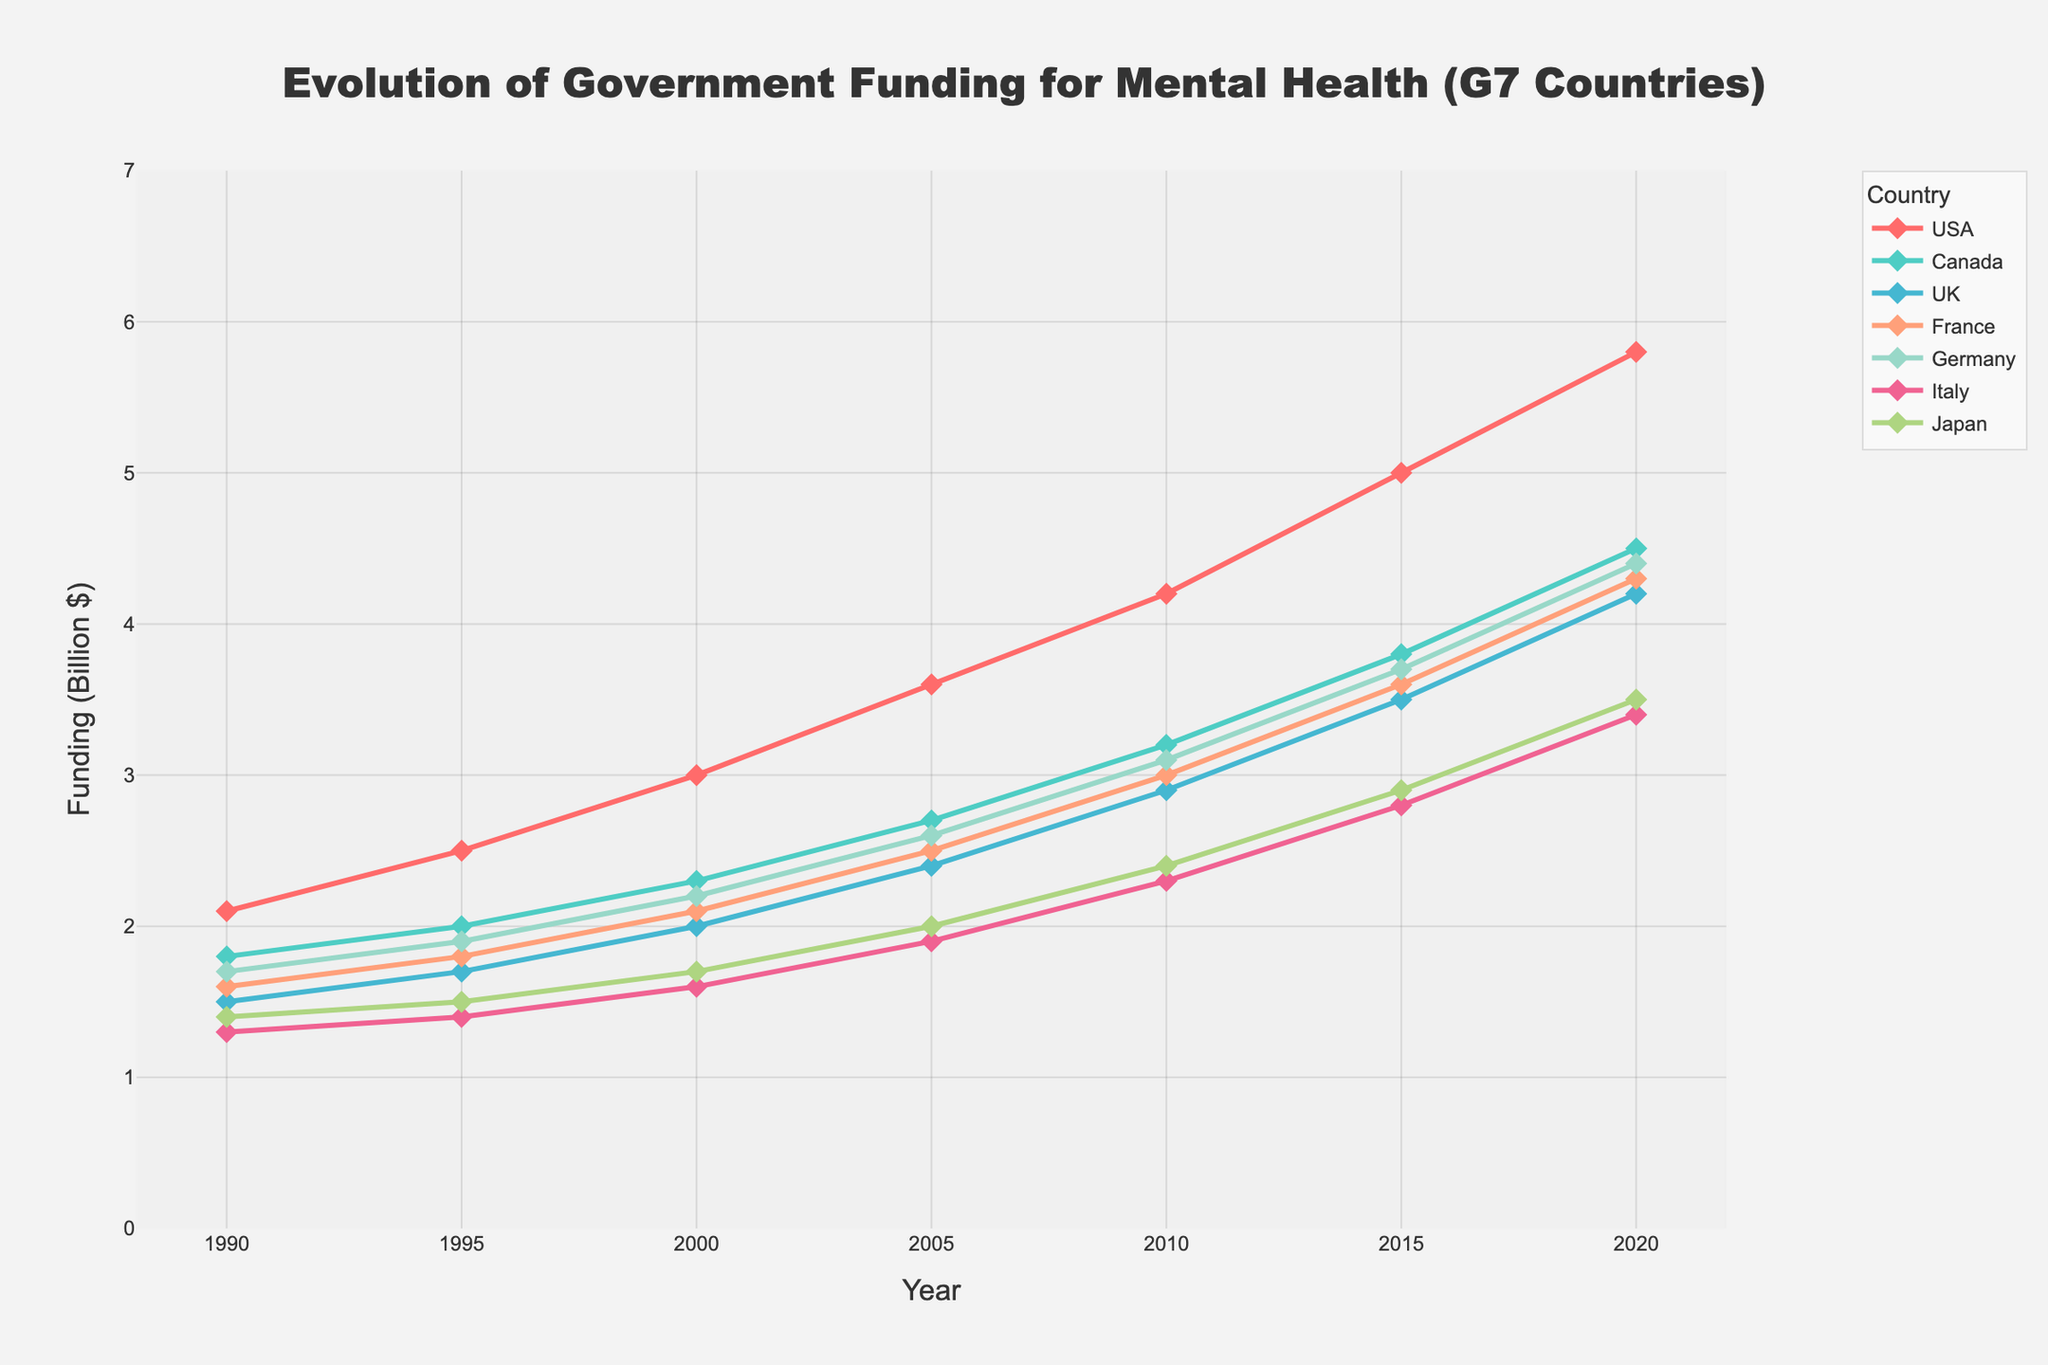What was the funding for mental health research and treatment programs in the USA in 1990 and 2020? To find the funding amount, look at the points corresponding to the USA line in 1990 and 2020. In 1990, it is $2.1 billion and in 2020, it is $5.8 billion.
Answer: $2.1 billion and $5.8 billion Which G7 country showed the greatest increase in funding from 1990 to 2020? Calculate the difference between the 2020 and 1990 values for each country. The differences are: USA (5.8 - 2.1 = 3.7), Canada (4.5 - 1.8 = 2.7), UK (4.2 - 1.5 = 2.7), France (4.3 - 1.6 = 2.7), Germany (4.4 - 1.7 = 2.7), Italy (3.4 - 1.3 = 2.1), and Japan (3.5 - 1.4 = 2.1). USA shows the greatest increase.
Answer: USA What's the average funding for mental health research and treatment programs in Germany from 1990 to 2020? Add Germany’s funding values over the years and divide by the number of years: (1.7 + 1.9 + 2.2 + 2.6 + 3.1 + 3.7 + 4.4) / 7. The sum is 19.6, so the average is 19.6/7 = 2.8.
Answer: $2.8 billion How did Japan's funding in 2010 compare to Italy's funding in the same year? Locate Japan’s funding in 2010, which is $2.4 billion, and Italy’s funding in 2010, which is $2.3 billion. Japan’s funding is slightly higher.
Answer: Japan's funding was slightly higher than Italy's Between 1990 and 2020, which country had the slowest growth in mental health funding? Calculate the growth (2020 value - 1990 value) for each country: USA (3.7), Canada (2.7), UK (2.7), France (2.7), Germany (2.7), Italy (2.1), Japan (2.1). Italy and Japan had the slowest growth.
Answer: Italy and Japan Calculate the total funding across all G7 countries in 2020. Add the funding amounts for all countries in 2020: 5.8 (USA) + 4.5 (Canada) + 4.2 (UK) + 4.3 (France) + 4.4 (Germany) + 3.4 (Italy) + 3.5 (Japan) equals 30.1.
Answer: $30.1 billion How did the funding trend for mental health research and treatment in the UK change from 2000 to 2020? Observe the UK funding trend starting at $2.0 billion in 2000, increasing steadily through 2005, 2010, 2015, and reaching $4.2 billion in 2020. The trend shows a consistent growth.
Answer: Consistent growth What visual pattern can you observe in the funding trends of Canada and the UK between 1990 and 2020? Look at the lines representing Canada and the UK. Both lines show a similar ascending trend over the years. However, Canada's line is above the UK's line throughout the period, indicating higher funding amounts.
Answer: Consistent ascending trends with Canada's funding higher than the UK's Among the G7 countries, which one had a funding crossing point with another country, and when did it occur? Look for points where two lines intersect. France and Germany lines cross between 2010 and 2015. Prior to 2010, France had higher funding, and after 2015, Germany had higher funding.
Answer: France and Germany between 2010 and 2015 What's the average annual increase in funding for the USA from 1990 to 2020? Calculate the total increase for the USA from 1990 to 2020: 5.8 - 2.1 = 3.7. Then, divide by the number of intervals, which is 6 (2020 - 1990 / 5-year intervals): 3.7 / 6 = 0.62.
Answer: $0.62 billion per year 